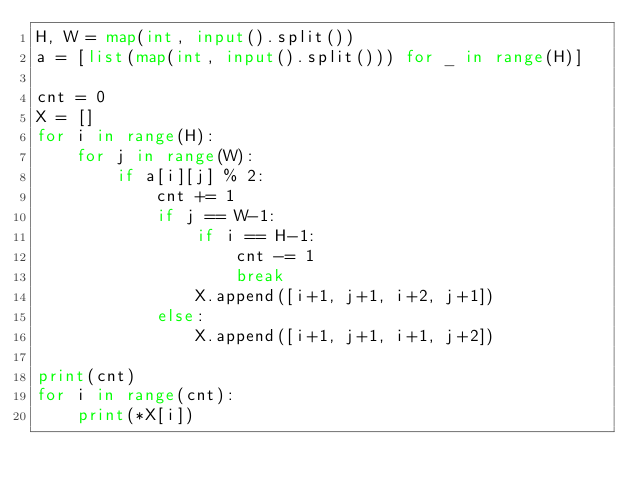Convert code to text. <code><loc_0><loc_0><loc_500><loc_500><_Python_>H, W = map(int, input().split())
a = [list(map(int, input().split())) for _ in range(H)]

cnt = 0
X = []
for i in range(H):
    for j in range(W):
        if a[i][j] % 2:
            cnt += 1
            if j == W-1:
                if i == H-1:
                    cnt -= 1
                    break
                X.append([i+1, j+1, i+2, j+1])
            else:
                X.append([i+1, j+1, i+1, j+2])

print(cnt)    
for i in range(cnt):
    print(*X[i])</code> 